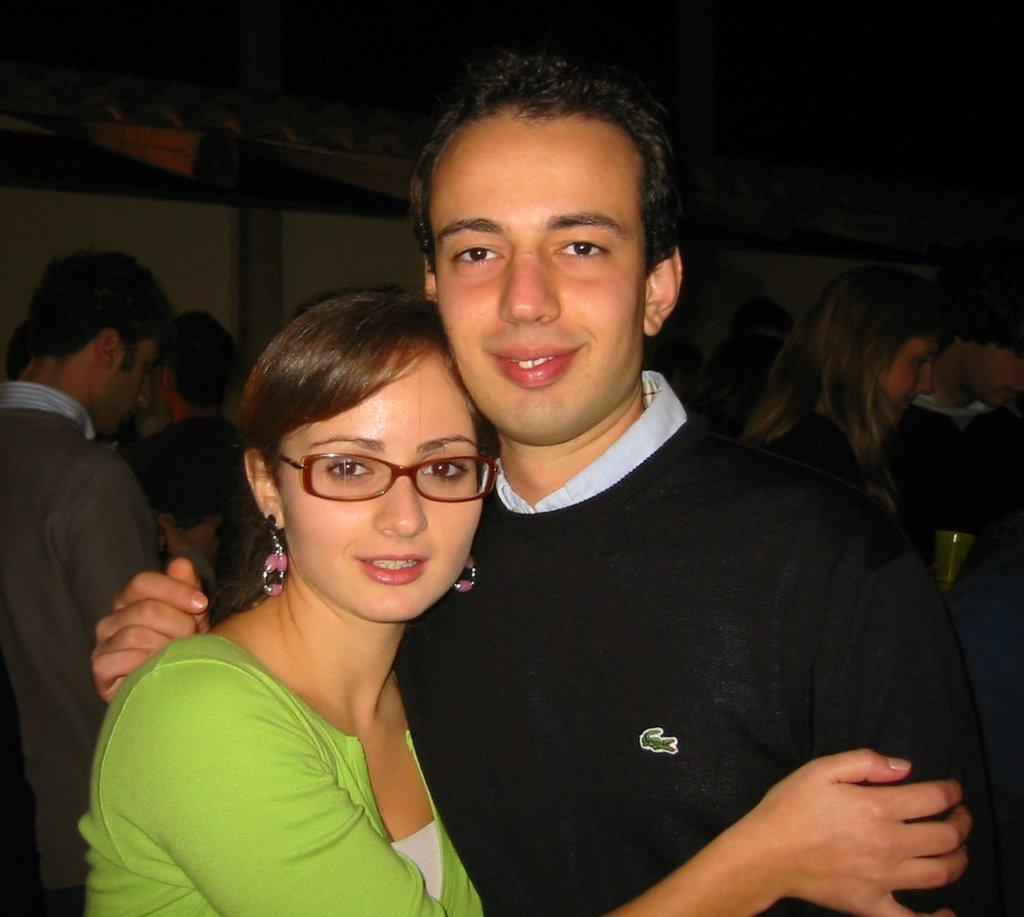What is the main subject of the image? There is a boy and a girl in the center of the image. Can you describe the positioning of the boy and girl in the image? The boy and girl are both in the center of the image. What else can be seen in the image besides the boy and girl? There are other people in the background of the image. What type of land can be seen in the image? There is no land visible in the image; it appears to be a close-up of the boy and girl. What action is the rod performing in the image? There is no rod present in the image, so it cannot be performing any action. 